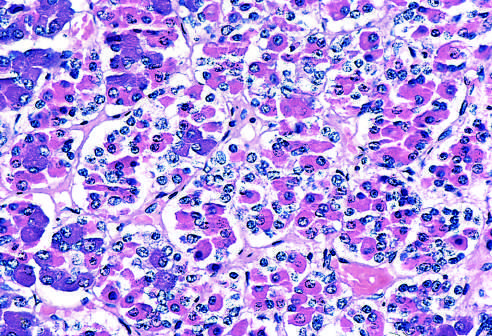what are basophilic (blue), eosinophilic (red), or nonstaining?
Answer the question using a single word or phrase. Peptide hormones 